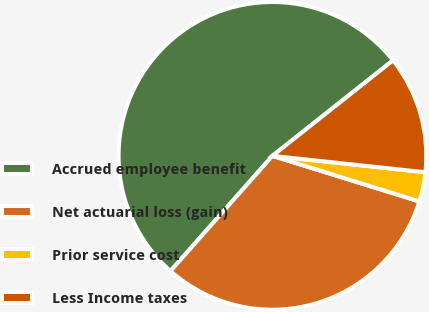Convert chart to OTSL. <chart><loc_0><loc_0><loc_500><loc_500><pie_chart><fcel>Accrued employee benefit<fcel>Net actuarial loss (gain)<fcel>Prior service cost<fcel>Less Income taxes<nl><fcel>52.81%<fcel>31.74%<fcel>3.09%<fcel>12.36%<nl></chart> 